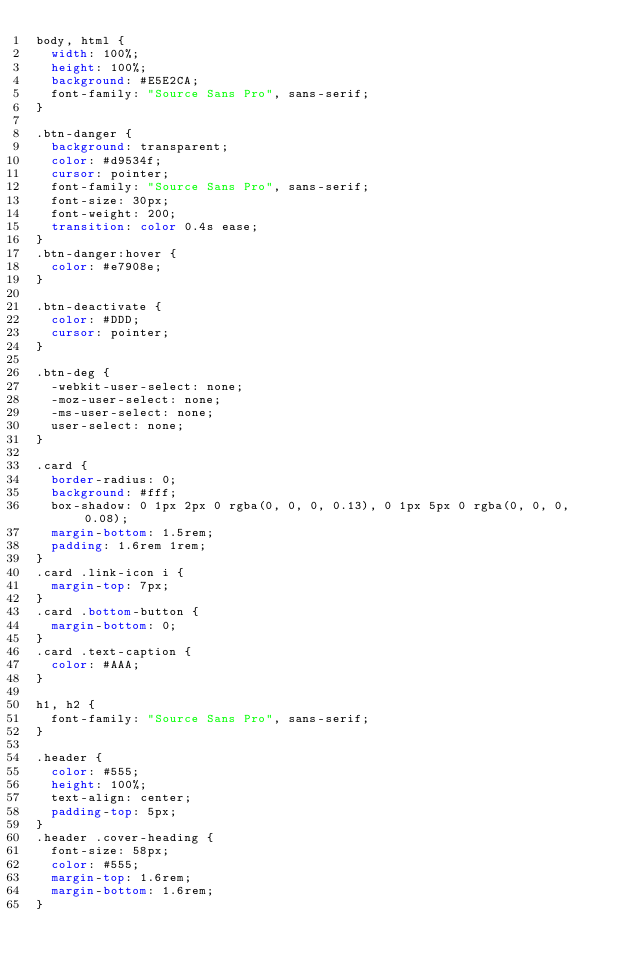<code> <loc_0><loc_0><loc_500><loc_500><_CSS_>body, html {
  width: 100%;
  height: 100%;
  background: #E5E2CA;
  font-family: "Source Sans Pro", sans-serif;
}

.btn-danger {
  background: transparent;
  color: #d9534f;
  cursor: pointer;
  font-family: "Source Sans Pro", sans-serif;
  font-size: 30px;
  font-weight: 200;
  transition: color 0.4s ease;
}
.btn-danger:hover {
  color: #e7908e;
}

.btn-deactivate {
  color: #DDD;
  cursor: pointer;
}

.btn-deg {
  -webkit-user-select: none;
  -moz-user-select: none;
  -ms-user-select: none;
  user-select: none;
}

.card {
  border-radius: 0;
  background: #fff;
  box-shadow: 0 1px 2px 0 rgba(0, 0, 0, 0.13), 0 1px 5px 0 rgba(0, 0, 0, 0.08);
  margin-bottom: 1.5rem;
  padding: 1.6rem 1rem;
}
.card .link-icon i {
  margin-top: 7px;
}
.card .bottom-button {
  margin-bottom: 0;
}
.card .text-caption {
  color: #AAA;
}

h1, h2 {
  font-family: "Source Sans Pro", sans-serif;
}

.header {
  color: #555;
  height: 100%;
  text-align: center;
  padding-top: 5px;
}
.header .cover-heading {
  font-size: 58px;
  color: #555;
  margin-top: 1.6rem;
  margin-bottom: 1.6rem;
}
</code> 